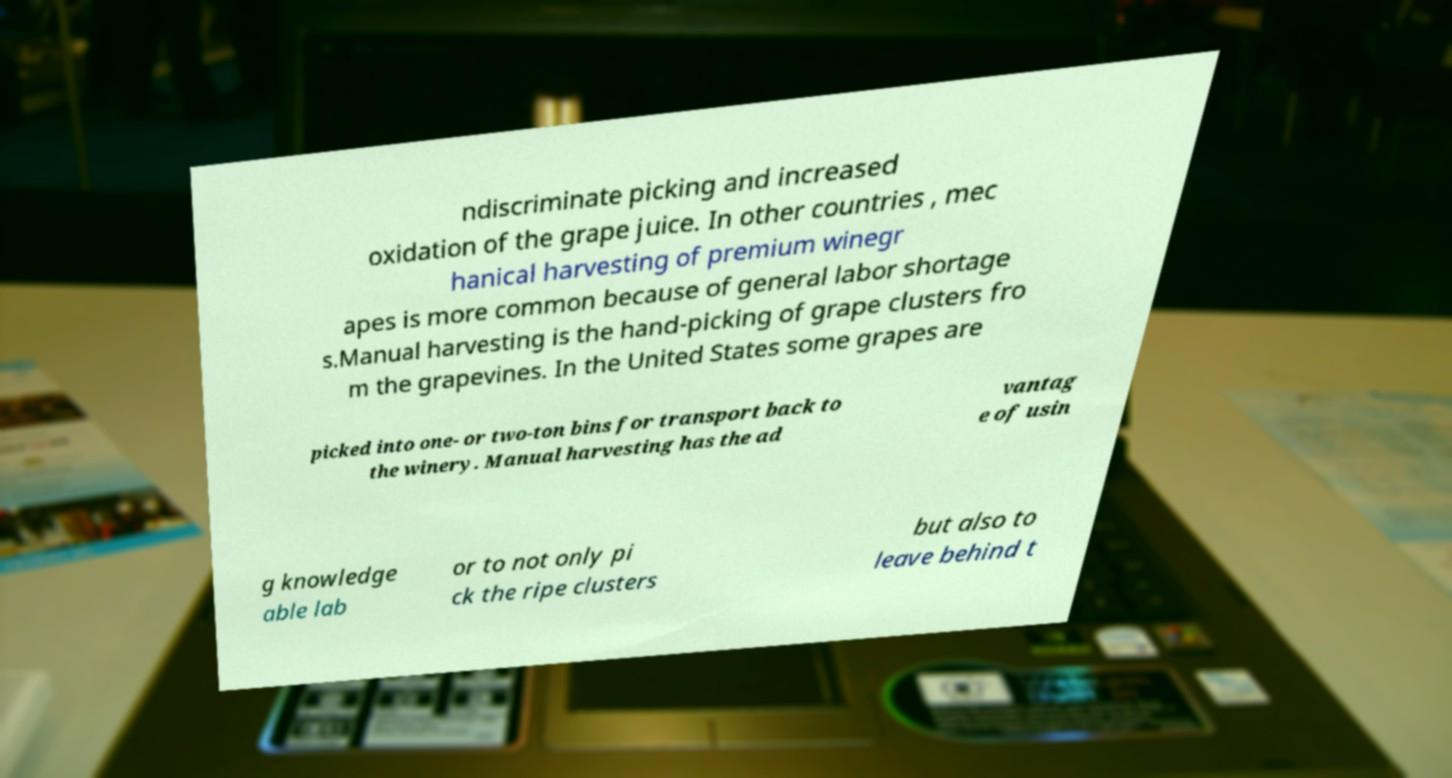There's text embedded in this image that I need extracted. Can you transcribe it verbatim? ndiscriminate picking and increased oxidation of the grape juice. In other countries , mec hanical harvesting of premium winegr apes is more common because of general labor shortage s.Manual harvesting is the hand-picking of grape clusters fro m the grapevines. In the United States some grapes are picked into one- or two-ton bins for transport back to the winery. Manual harvesting has the ad vantag e of usin g knowledge able lab or to not only pi ck the ripe clusters but also to leave behind t 